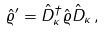<formula> <loc_0><loc_0><loc_500><loc_500>\hat { \varrho } ^ { \prime } = \hat { D } _ { \kappa } ^ { \dag } \hat { \varrho } \hat { D } _ { \kappa } \, ,</formula> 